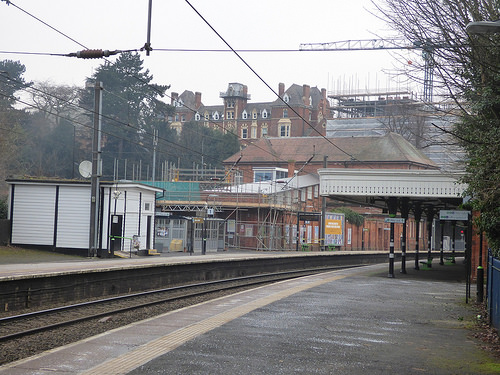<image>
Is there a platform behind the building? No. The platform is not behind the building. From this viewpoint, the platform appears to be positioned elsewhere in the scene. 